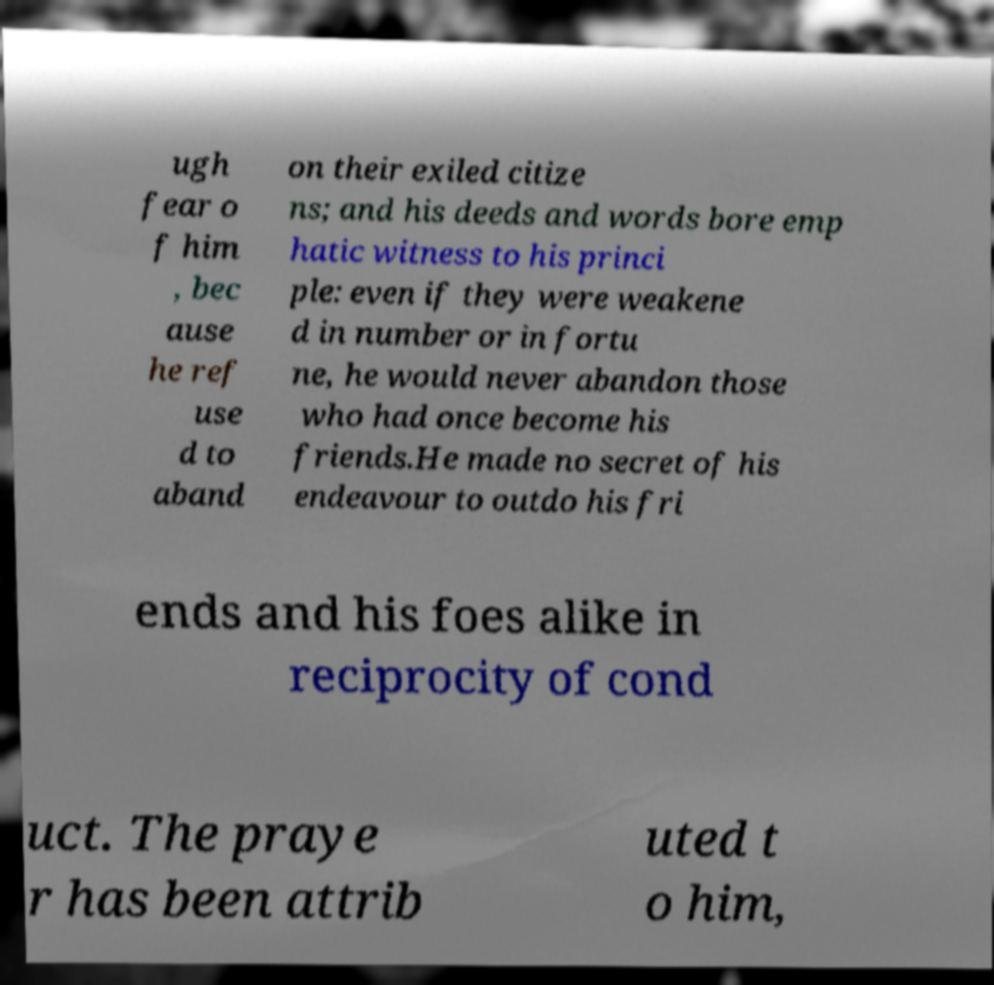Can you read and provide the text displayed in the image?This photo seems to have some interesting text. Can you extract and type it out for me? ugh fear o f him , bec ause he ref use d to aband on their exiled citize ns; and his deeds and words bore emp hatic witness to his princi ple: even if they were weakene d in number or in fortu ne, he would never abandon those who had once become his friends.He made no secret of his endeavour to outdo his fri ends and his foes alike in reciprocity of cond uct. The praye r has been attrib uted t o him, 